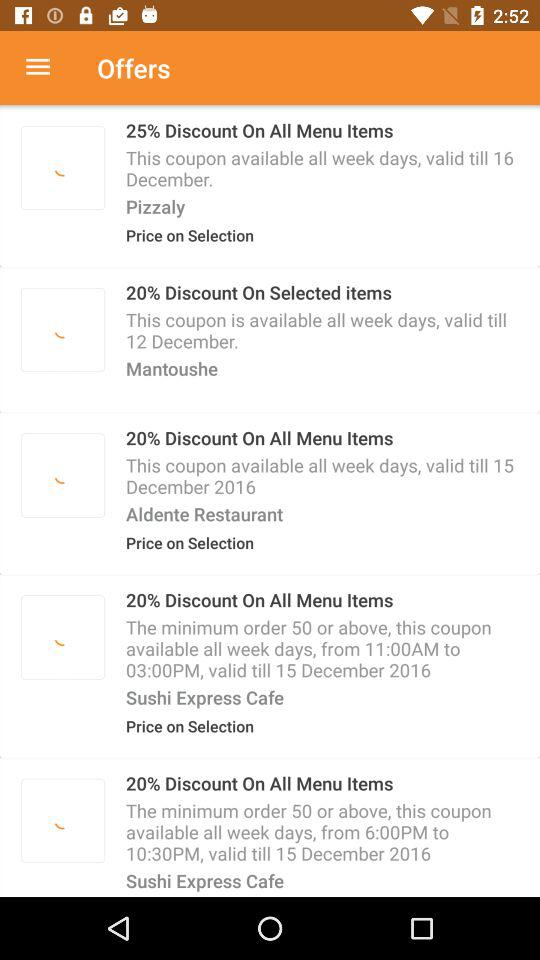How much is the discounted offer on Mantoushe? The offer on Mantoushe is a 20% discount on selected items. 